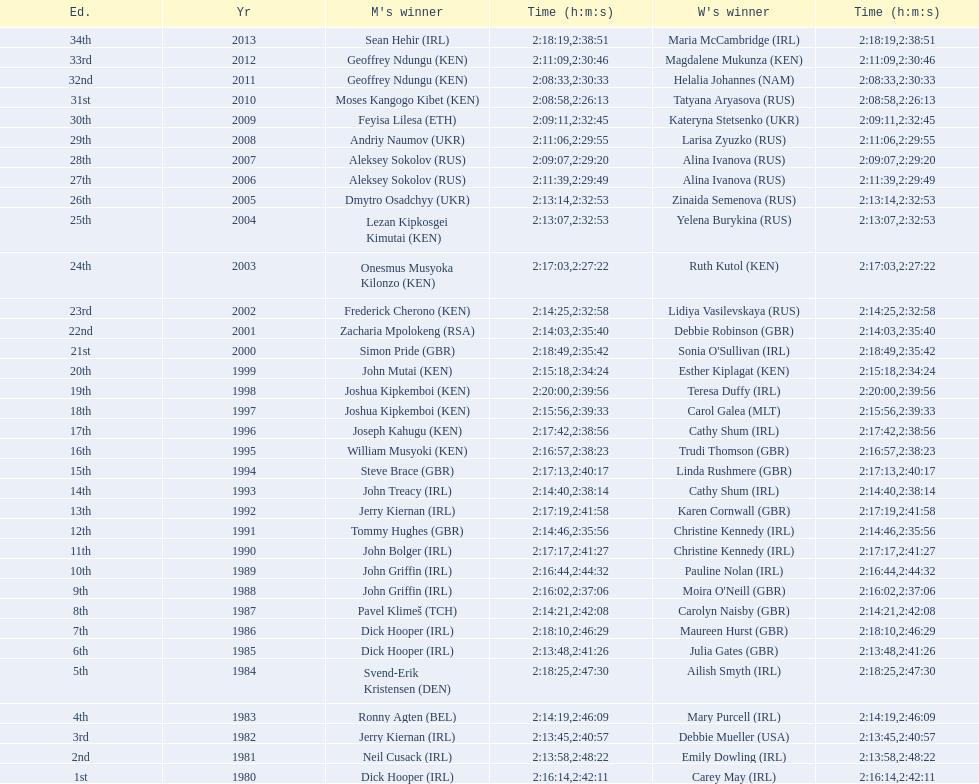Which athlete had a faster finish in 2009 - the male competitor or the female competitor? Male. 